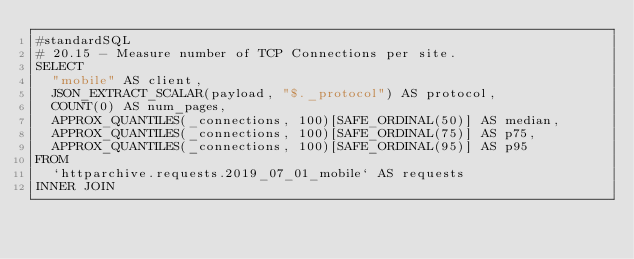<code> <loc_0><loc_0><loc_500><loc_500><_SQL_>#standardSQL
# 20.15 - Measure number of TCP Connections per site.
SELECT
  "mobile" AS client,
  JSON_EXTRACT_SCALAR(payload, "$._protocol") AS protocol,
  COUNT(0) AS num_pages,
  APPROX_QUANTILES(_connections, 100)[SAFE_ORDINAL(50)] AS median,
  APPROX_QUANTILES(_connections, 100)[SAFE_ORDINAL(75)] AS p75,
  APPROX_QUANTILES(_connections, 100)[SAFE_ORDINAL(95)] AS p95
FROM
  `httparchive.requests.2019_07_01_mobile` AS requests
INNER JOIN</code> 